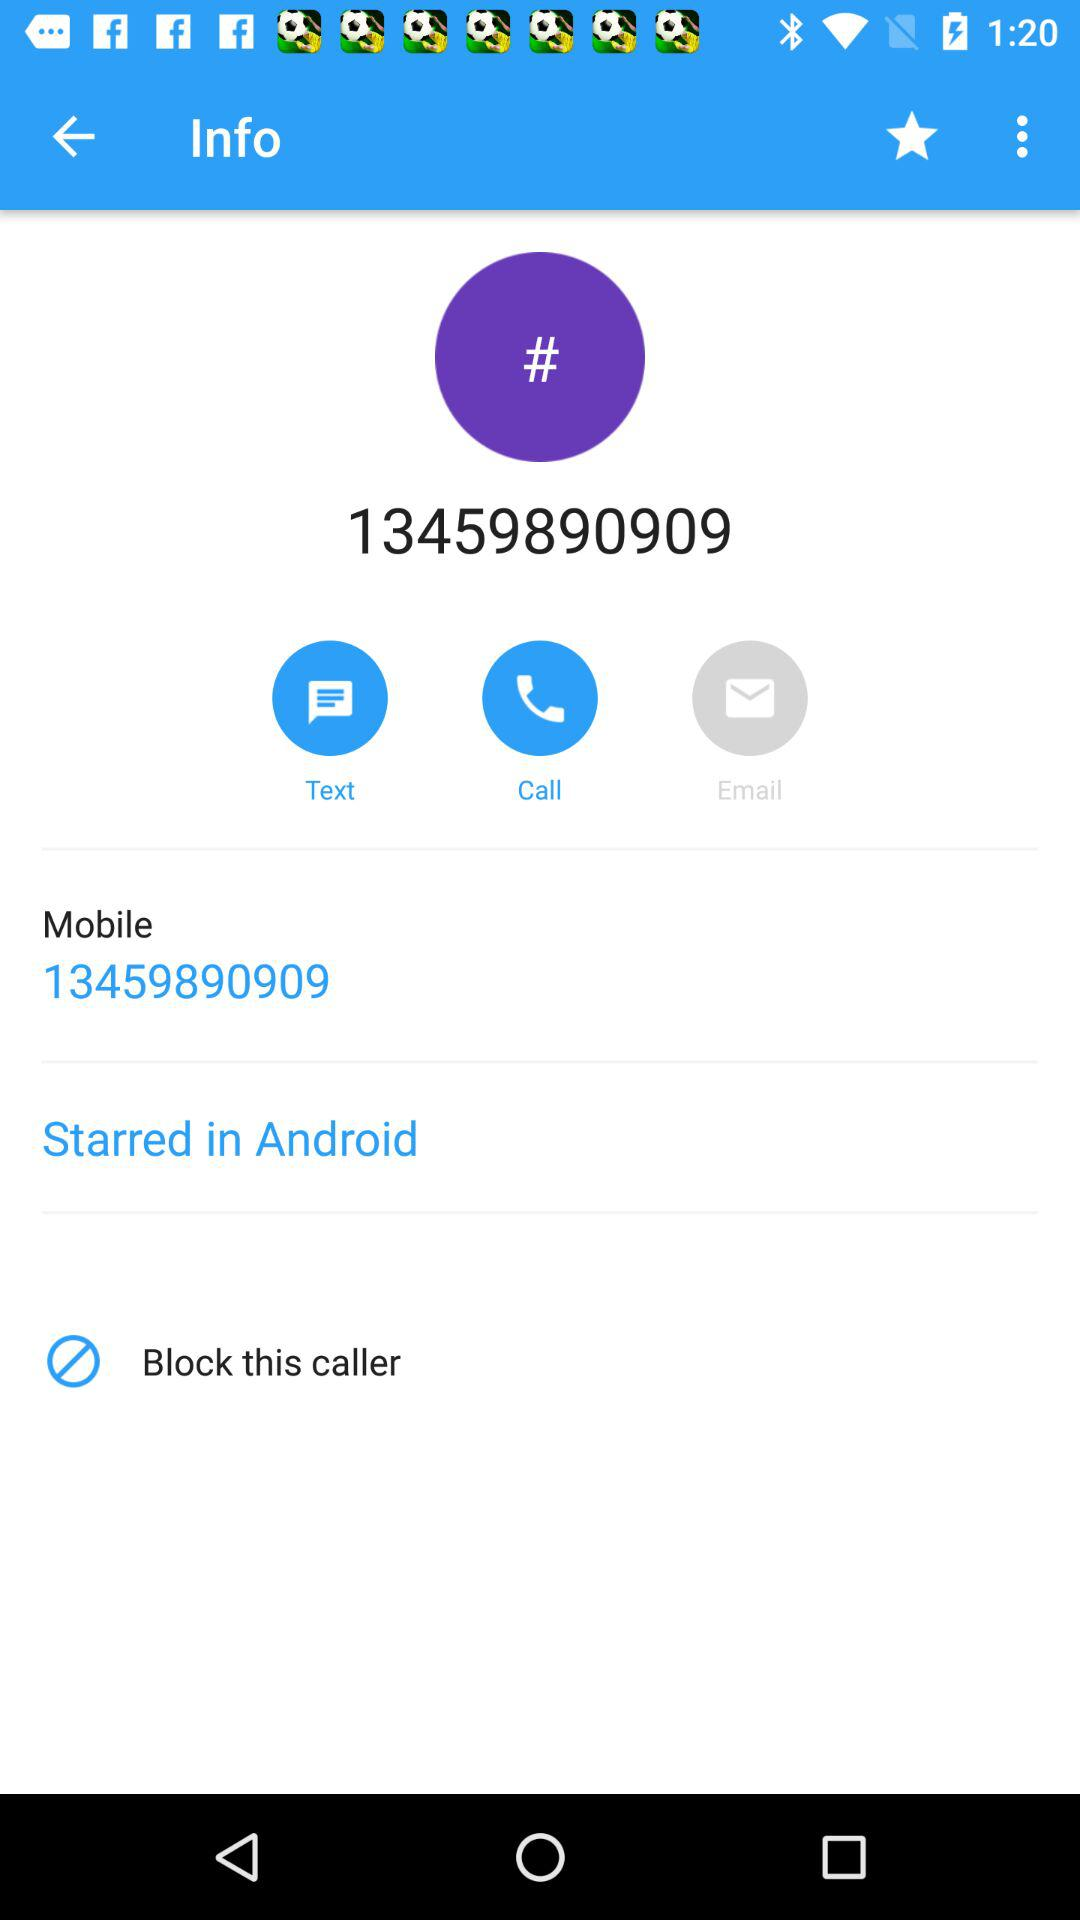What is the selected tab?
When the provided information is insufficient, respond with <no answer>. <no answer> 